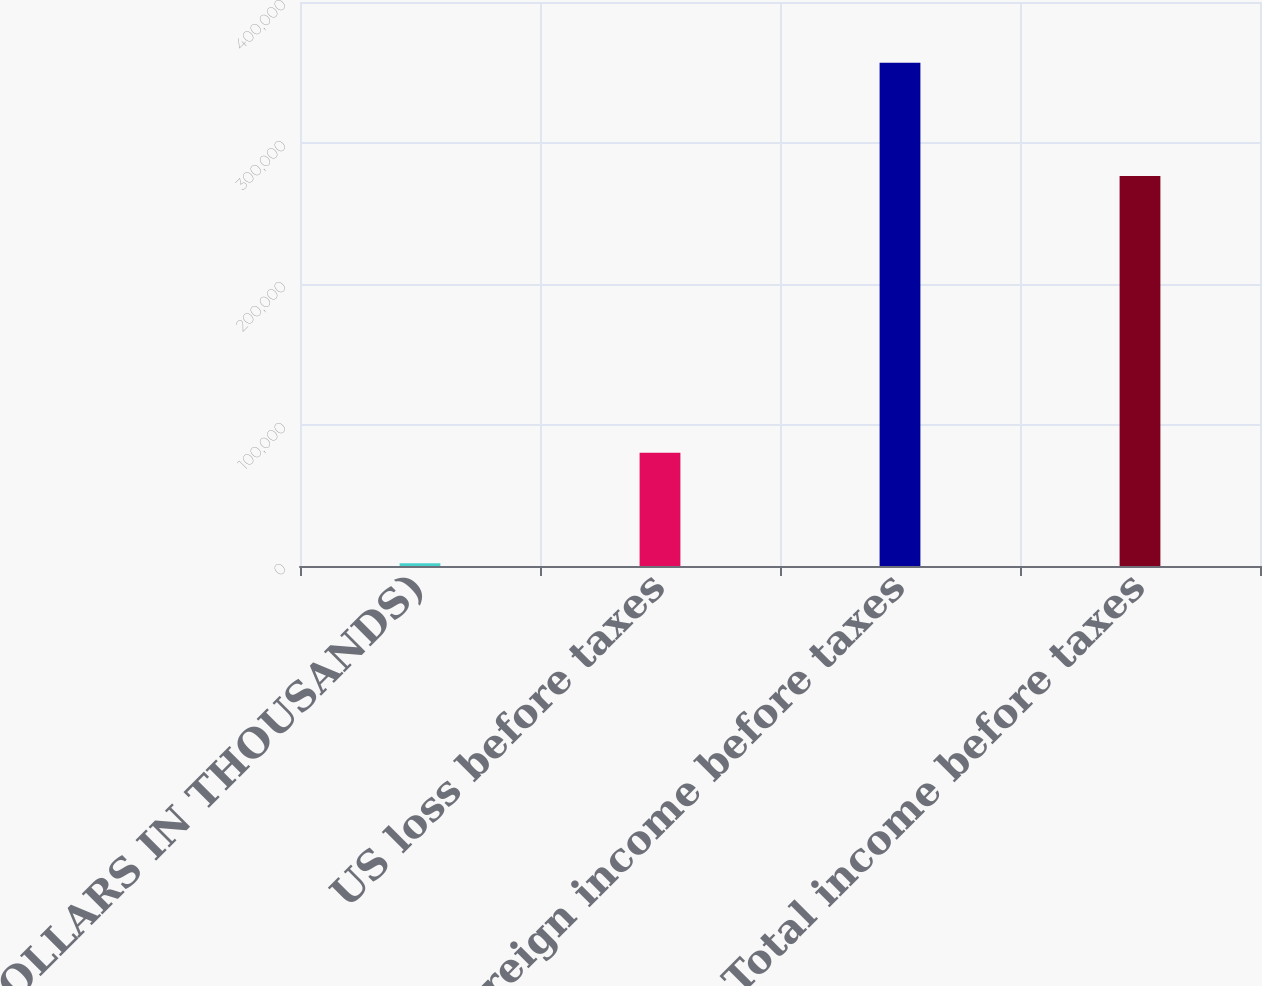Convert chart to OTSL. <chart><loc_0><loc_0><loc_500><loc_500><bar_chart><fcel>(DOLLARS IN THOUSANDS)<fcel>US loss before taxes<fcel>Foreign income before taxes<fcel>Total income before taxes<nl><fcel>2009<fcel>80345<fcel>356894<fcel>276549<nl></chart> 